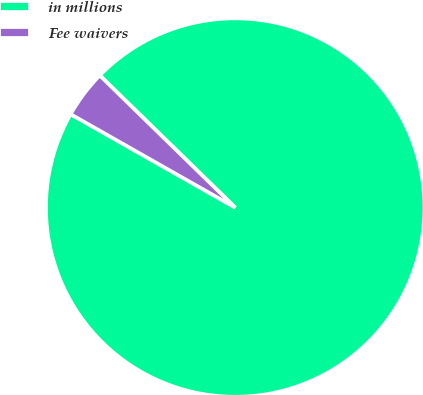<chart> <loc_0><loc_0><loc_500><loc_500><pie_chart><fcel>in millions<fcel>Fee waivers<nl><fcel>95.91%<fcel>4.09%<nl></chart> 